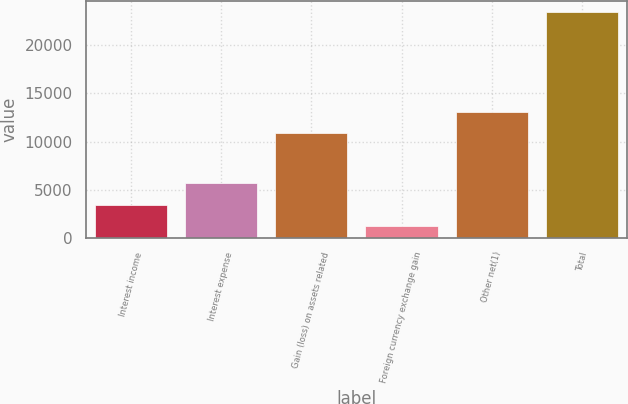<chart> <loc_0><loc_0><loc_500><loc_500><bar_chart><fcel>Interest income<fcel>Interest expense<fcel>Gain (loss) on assets related<fcel>Foreign currency exchange gain<fcel>Other net(1)<fcel>Total<nl><fcel>3418<fcel>5641<fcel>10856<fcel>1195<fcel>13079<fcel>23425<nl></chart> 